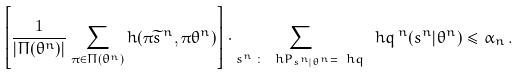Convert formula to latex. <formula><loc_0><loc_0><loc_500><loc_500>\left [ \frac { 1 } { | \Pi ( \theta ^ { n } ) | } \sum _ { \pi \in \Pi ( \theta ^ { n } ) } h ( \pi \widetilde { s } ^ { \, n } , \pi \theta ^ { n } ) \right ] \cdot \sum _ { s ^ { n } \, \colon \, \ h P _ { s ^ { n } | \theta ^ { n } } = \ h q } \ h q ^ { \, n } ( s ^ { n } | \theta ^ { n } ) \leq \alpha _ { n } \, .</formula> 